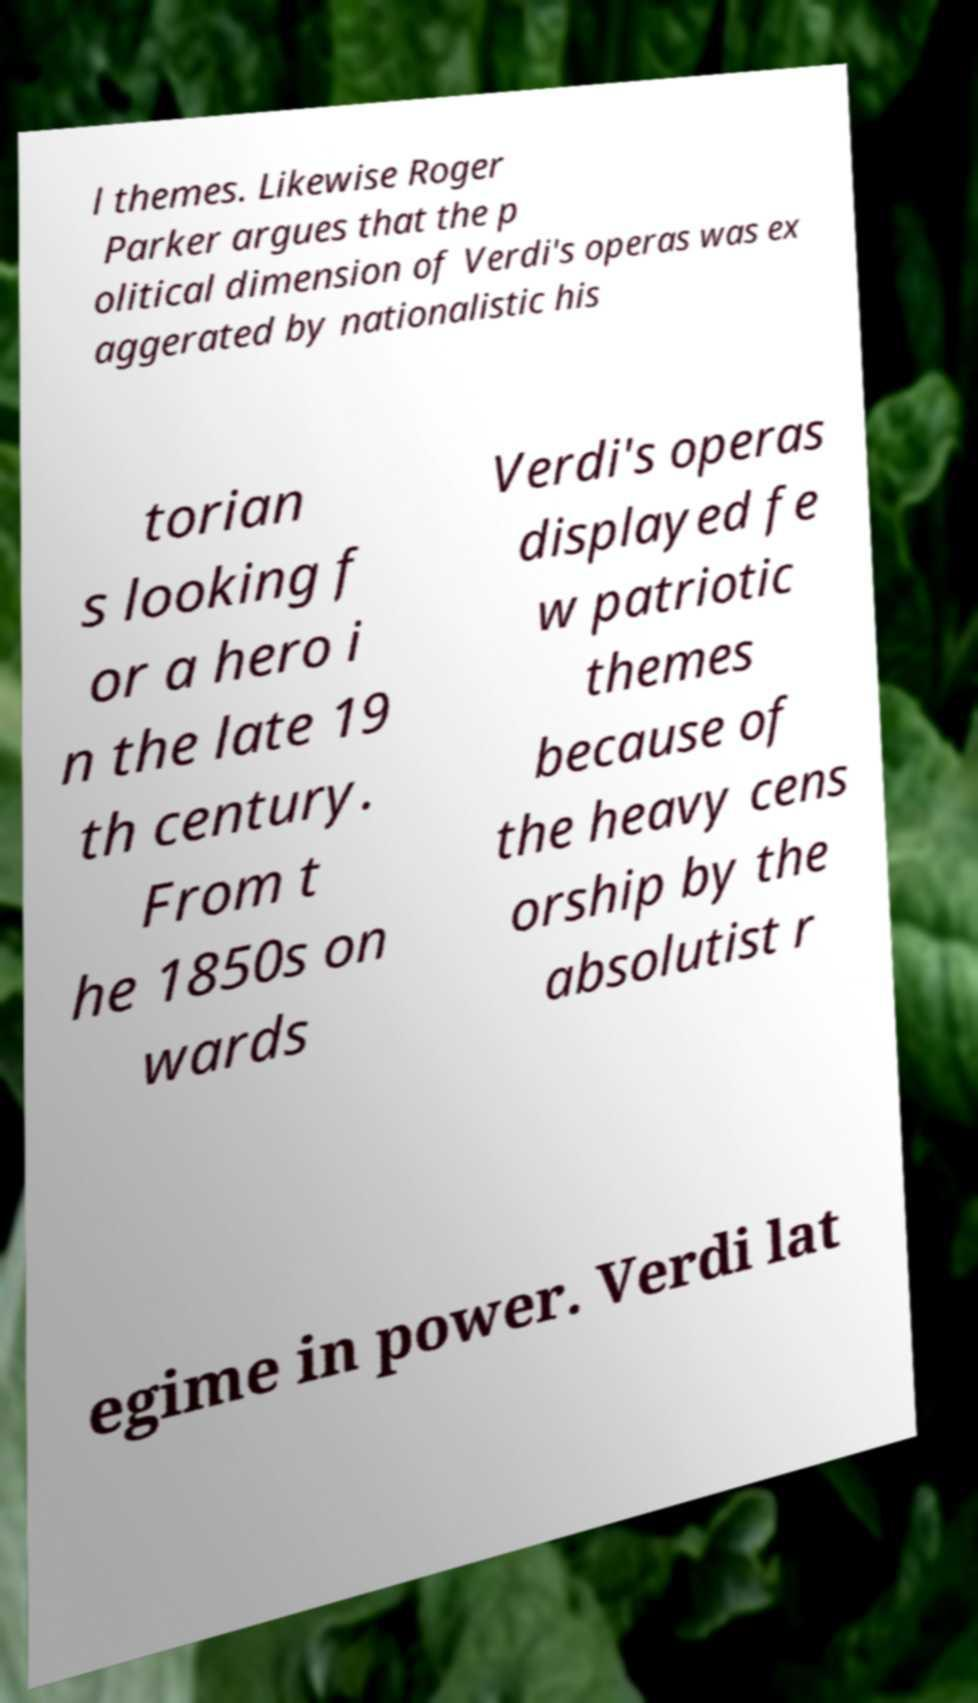Please identify and transcribe the text found in this image. l themes. Likewise Roger Parker argues that the p olitical dimension of Verdi's operas was ex aggerated by nationalistic his torian s looking f or a hero i n the late 19 th century. From t he 1850s on wards Verdi's operas displayed fe w patriotic themes because of the heavy cens orship by the absolutist r egime in power. Verdi lat 